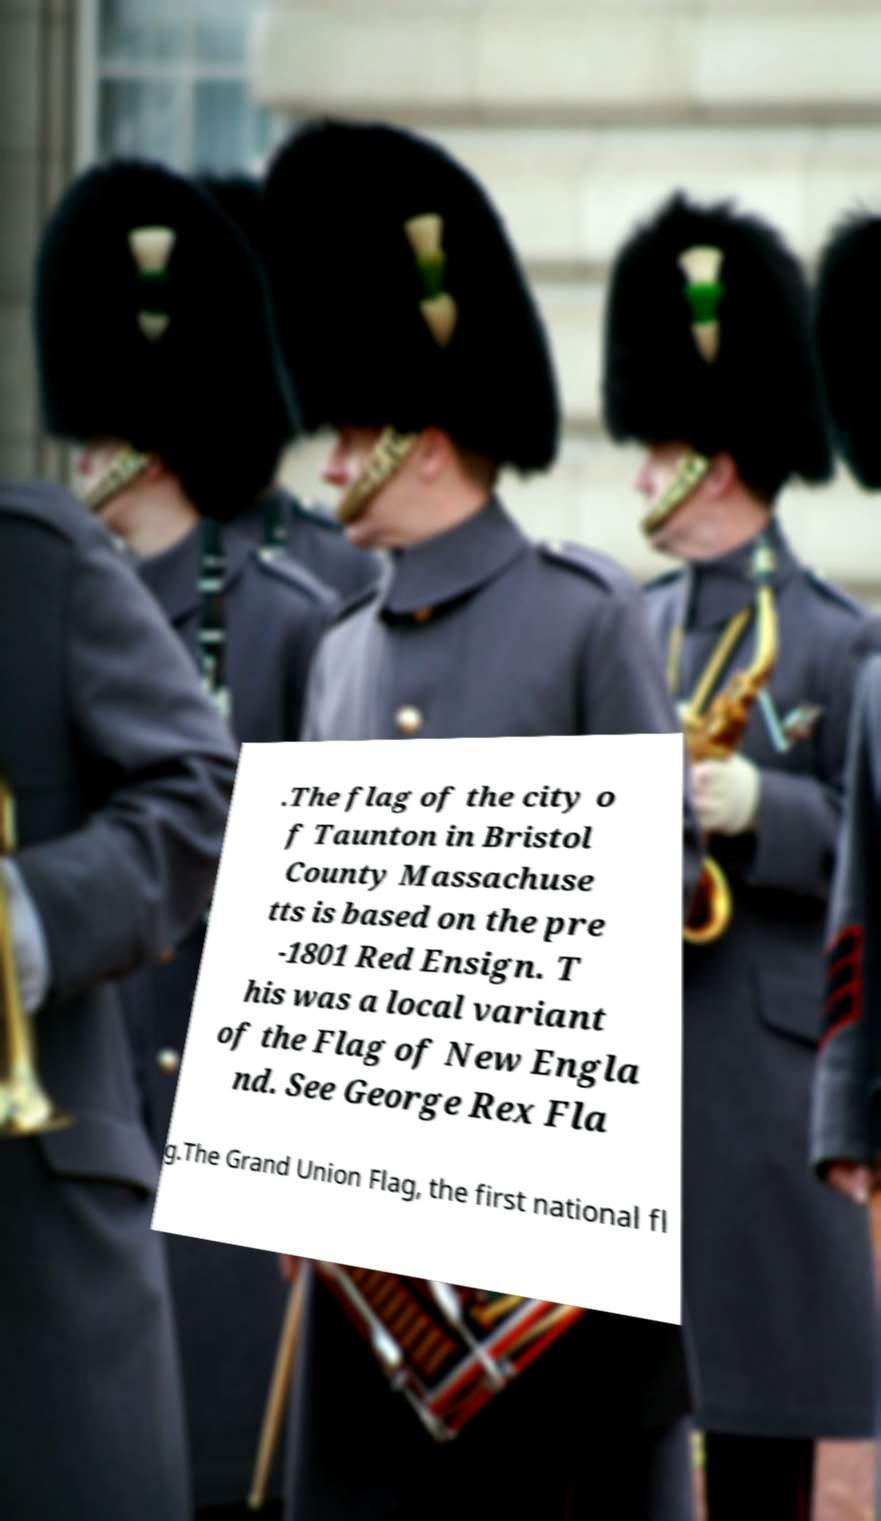Could you extract and type out the text from this image? .The flag of the city o f Taunton in Bristol County Massachuse tts is based on the pre -1801 Red Ensign. T his was a local variant of the Flag of New Engla nd. See George Rex Fla g.The Grand Union Flag, the first national fl 